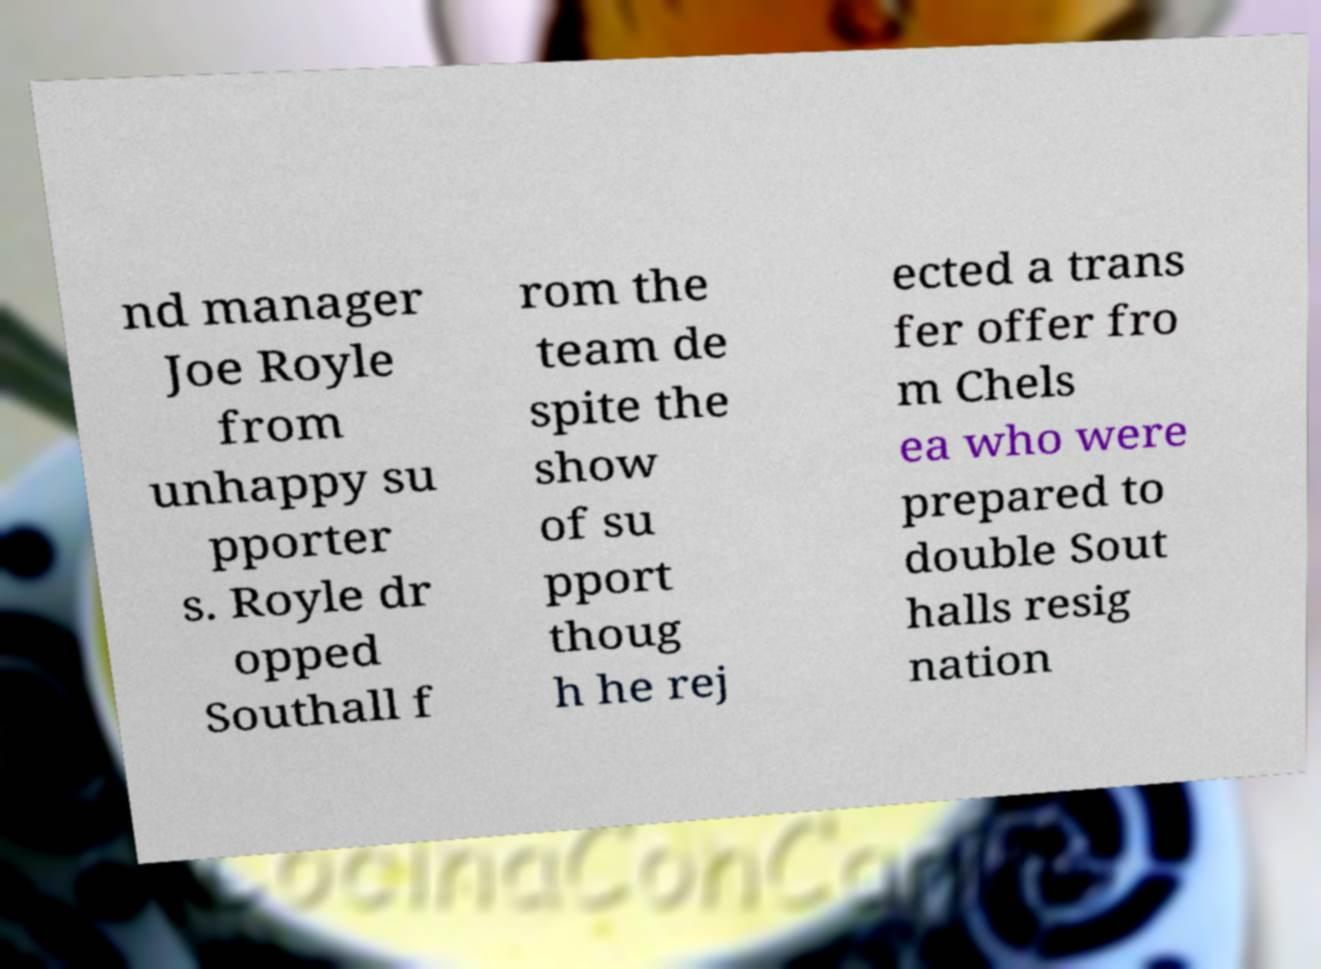For documentation purposes, I need the text within this image transcribed. Could you provide that? nd manager Joe Royle from unhappy su pporter s. Royle dr opped Southall f rom the team de spite the show of su pport thoug h he rej ected a trans fer offer fro m Chels ea who were prepared to double Sout halls resig nation 